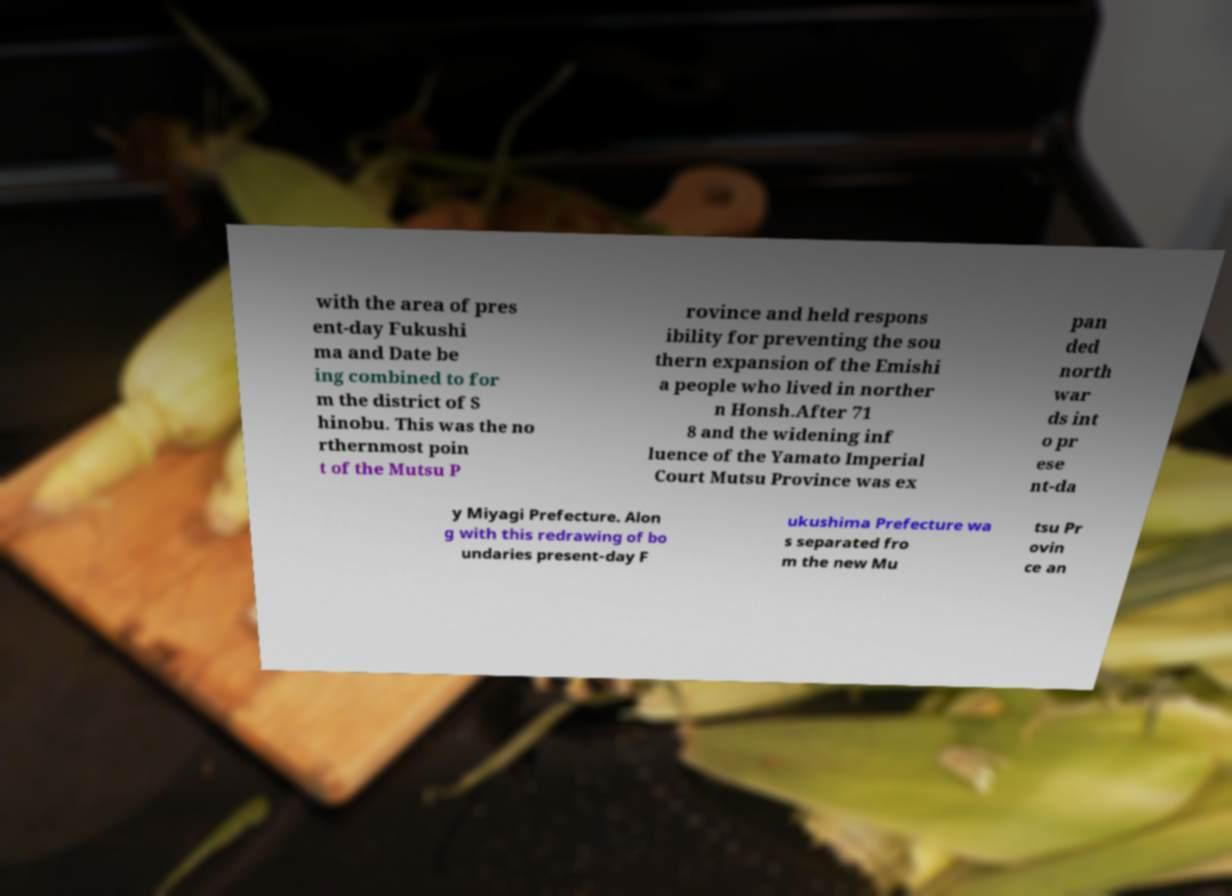What messages or text are displayed in this image? I need them in a readable, typed format. with the area of pres ent-day Fukushi ma and Date be ing combined to for m the district of S hinobu. This was the no rthernmost poin t of the Mutsu P rovince and held respons ibility for preventing the sou thern expansion of the Emishi a people who lived in norther n Honsh.After 71 8 and the widening inf luence of the Yamato Imperial Court Mutsu Province was ex pan ded north war ds int o pr ese nt-da y Miyagi Prefecture. Alon g with this redrawing of bo undaries present-day F ukushima Prefecture wa s separated fro m the new Mu tsu Pr ovin ce an 